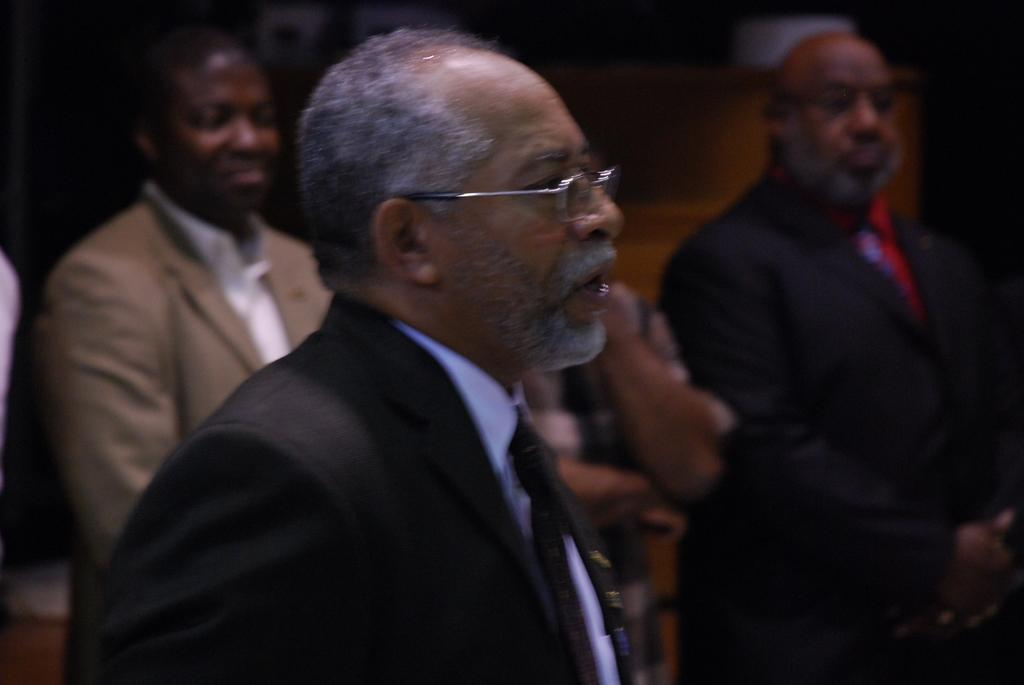How many people are in the image? There is a group of persons in the image. Can you describe the attire of one of the persons? One person is wearing a coat, a tie, and spectacles. How much money is the person holding in the image? There is no indication in the image that the person is holding any money. What type of thread is being used to sew the coat in the image? There is no visible thread in the image, and the type of thread used to sew the coat is not mentioned. 